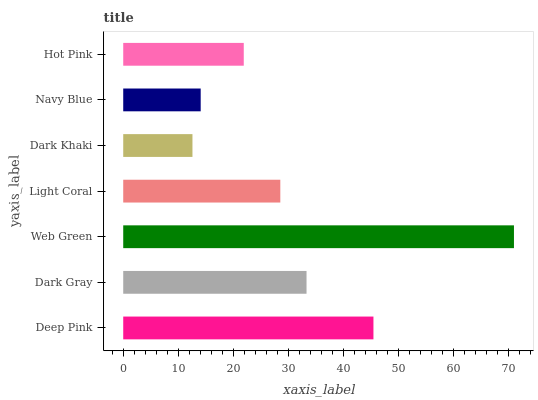Is Dark Khaki the minimum?
Answer yes or no. Yes. Is Web Green the maximum?
Answer yes or no. Yes. Is Dark Gray the minimum?
Answer yes or no. No. Is Dark Gray the maximum?
Answer yes or no. No. Is Deep Pink greater than Dark Gray?
Answer yes or no. Yes. Is Dark Gray less than Deep Pink?
Answer yes or no. Yes. Is Dark Gray greater than Deep Pink?
Answer yes or no. No. Is Deep Pink less than Dark Gray?
Answer yes or no. No. Is Light Coral the high median?
Answer yes or no. Yes. Is Light Coral the low median?
Answer yes or no. Yes. Is Deep Pink the high median?
Answer yes or no. No. Is Deep Pink the low median?
Answer yes or no. No. 